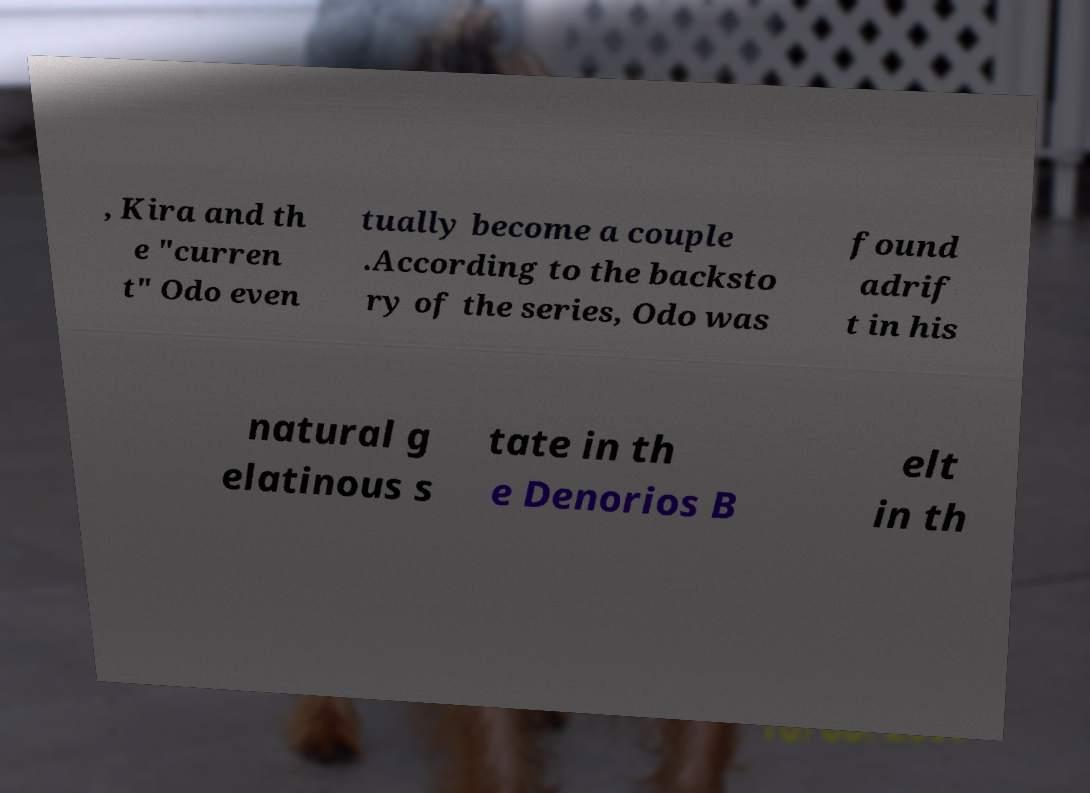For documentation purposes, I need the text within this image transcribed. Could you provide that? , Kira and th e "curren t" Odo even tually become a couple .According to the backsto ry of the series, Odo was found adrif t in his natural g elatinous s tate in th e Denorios B elt in th 